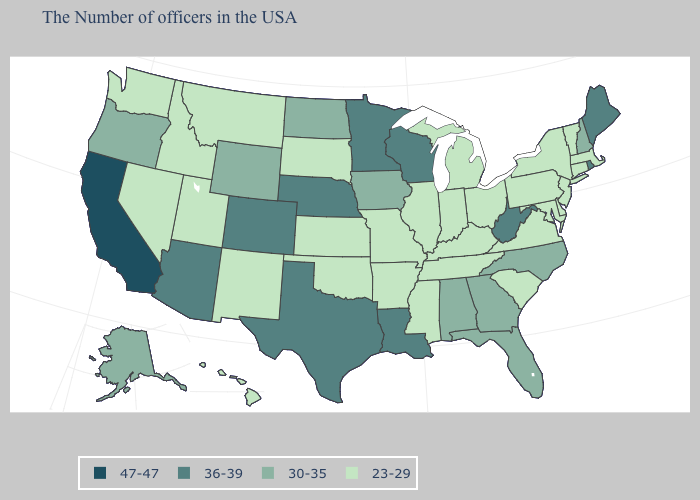What is the value of Utah?
Keep it brief. 23-29. What is the value of Missouri?
Quick response, please. 23-29. Name the states that have a value in the range 23-29?
Be succinct. Massachusetts, Vermont, Connecticut, New York, New Jersey, Delaware, Maryland, Pennsylvania, Virginia, South Carolina, Ohio, Michigan, Kentucky, Indiana, Tennessee, Illinois, Mississippi, Missouri, Arkansas, Kansas, Oklahoma, South Dakota, New Mexico, Utah, Montana, Idaho, Nevada, Washington, Hawaii. Name the states that have a value in the range 30-35?
Concise answer only. New Hampshire, North Carolina, Florida, Georgia, Alabama, Iowa, North Dakota, Wyoming, Oregon, Alaska. Does Montana have a lower value than Wyoming?
Be succinct. Yes. Does Nebraska have the lowest value in the MidWest?
Keep it brief. No. Name the states that have a value in the range 23-29?
Concise answer only. Massachusetts, Vermont, Connecticut, New York, New Jersey, Delaware, Maryland, Pennsylvania, Virginia, South Carolina, Ohio, Michigan, Kentucky, Indiana, Tennessee, Illinois, Mississippi, Missouri, Arkansas, Kansas, Oklahoma, South Dakota, New Mexico, Utah, Montana, Idaho, Nevada, Washington, Hawaii. What is the lowest value in the USA?
Keep it brief. 23-29. Name the states that have a value in the range 23-29?
Keep it brief. Massachusetts, Vermont, Connecticut, New York, New Jersey, Delaware, Maryland, Pennsylvania, Virginia, South Carolina, Ohio, Michigan, Kentucky, Indiana, Tennessee, Illinois, Mississippi, Missouri, Arkansas, Kansas, Oklahoma, South Dakota, New Mexico, Utah, Montana, Idaho, Nevada, Washington, Hawaii. Which states have the highest value in the USA?
Be succinct. California. What is the value of Kentucky?
Concise answer only. 23-29. Does Vermont have the same value as Delaware?
Quick response, please. Yes. Does the map have missing data?
Answer briefly. No. Does Oregon have the lowest value in the USA?
Concise answer only. No. 